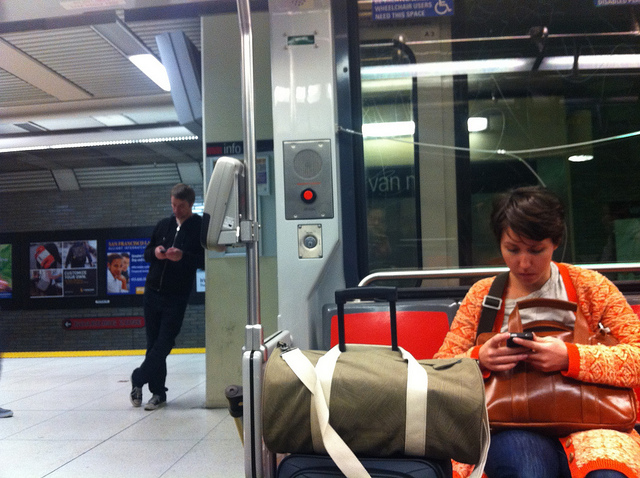Read and extract the text from this image. info Van 